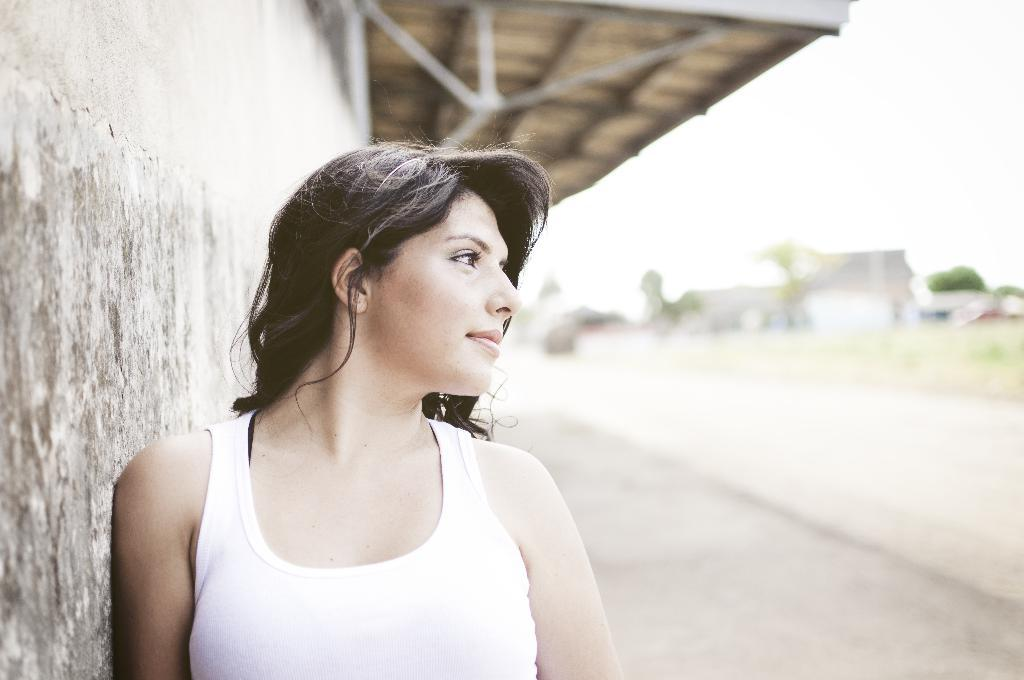Who is present in the image? There is a woman in the image. What is the woman wearing? The woman is wearing a white t-shirt. What can be seen on the left side of the image? There is a wall on the left side of the image. What architectural feature is visible in the image? There is a roof visible in the image. How would you describe the background of the image? The background of the image is blurred. What type of bottle is the woman holding in the image? There is no bottle present in the image; the woman is not holding anything. What kind of yarn is the woman using to knit in the image? There is no yarn or knitting activity present in the image. 